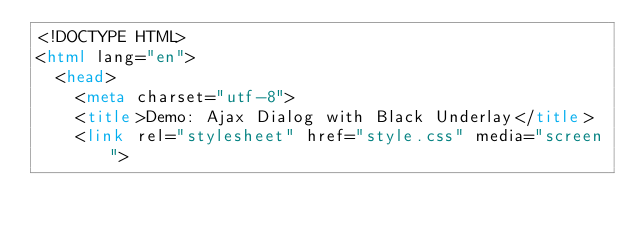<code> <loc_0><loc_0><loc_500><loc_500><_HTML_><!DOCTYPE HTML>
<html lang="en">
	<head>
		<meta charset="utf-8">
		<title>Demo: Ajax Dialog with Black Underlay</title>
		<link rel="stylesheet" href="style.css" media="screen">
</code> 